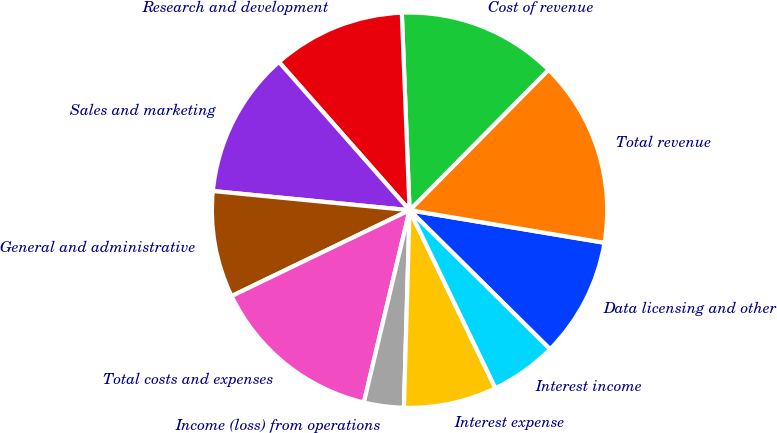Convert chart. <chart><loc_0><loc_0><loc_500><loc_500><pie_chart><fcel>Data licensing and other<fcel>Total revenue<fcel>Cost of revenue<fcel>Research and development<fcel>Sales and marketing<fcel>General and administrative<fcel>Total costs and expenses<fcel>Income (loss) from operations<fcel>Interest expense<fcel>Interest income<nl><fcel>9.78%<fcel>15.22%<fcel>13.04%<fcel>10.87%<fcel>11.96%<fcel>8.7%<fcel>14.13%<fcel>3.26%<fcel>7.61%<fcel>5.43%<nl></chart> 